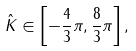<formula> <loc_0><loc_0><loc_500><loc_500>\hat { K } \in \left [ - \frac { 4 } { 3 } \pi , \frac { 8 } { 3 } \pi \right ] ,</formula> 